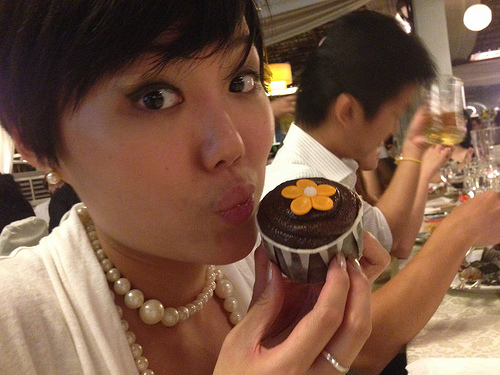What is the drink to the right of the dessert with the flower? The drink to the right of the dessert with the flower is beer. 